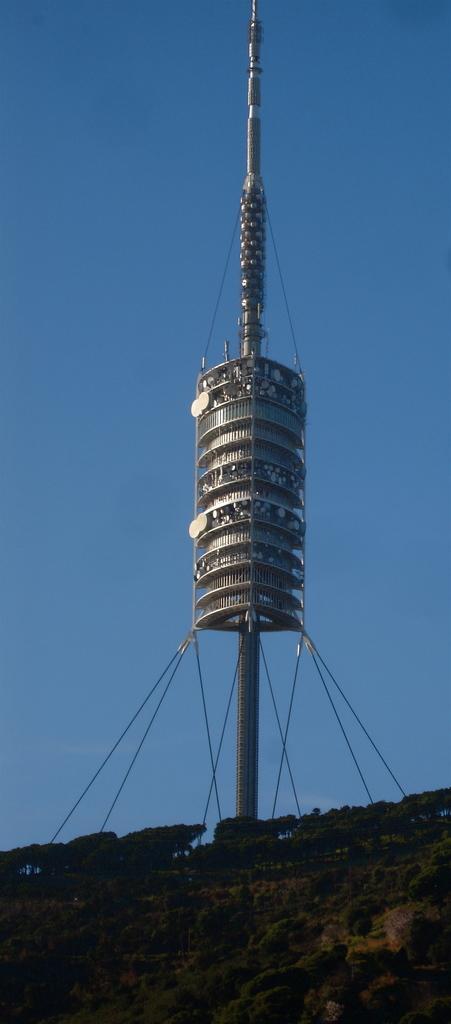Could you give a brief overview of what you see in this image? In the background we can see the sky. In this picture we can see a tower, trees, plants and ropes. 